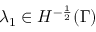<formula> <loc_0><loc_0><loc_500><loc_500>\lambda _ { 1 } \in H ^ { - \frac { 1 } { 2 } } ( \Gamma )</formula> 